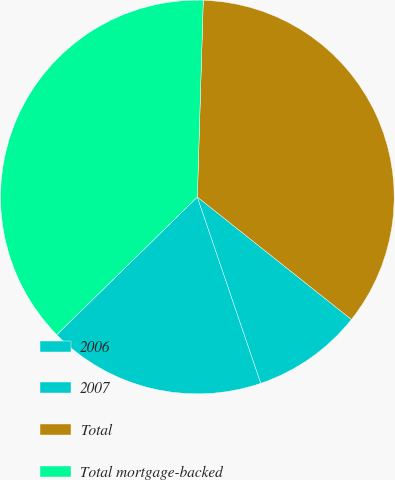Convert chart to OTSL. <chart><loc_0><loc_0><loc_500><loc_500><pie_chart><fcel>2006<fcel>2007<fcel>Total<fcel>Total mortgage-backed<nl><fcel>17.89%<fcel>9.09%<fcel>35.21%<fcel>37.82%<nl></chart> 